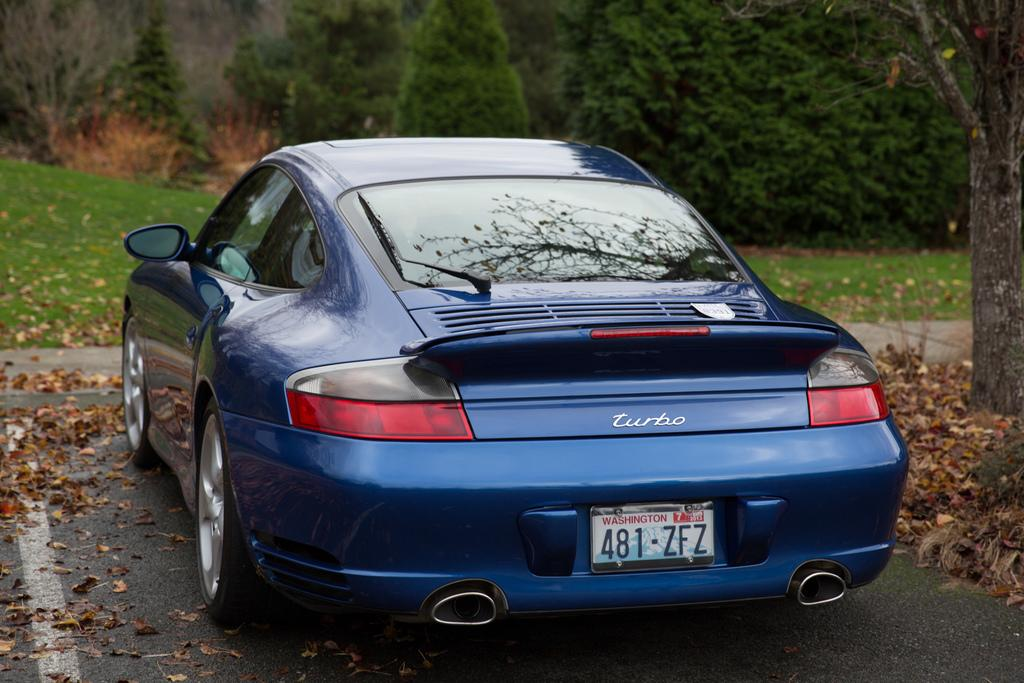<image>
Give a short and clear explanation of the subsequent image. a car that has 481 on the back of it 